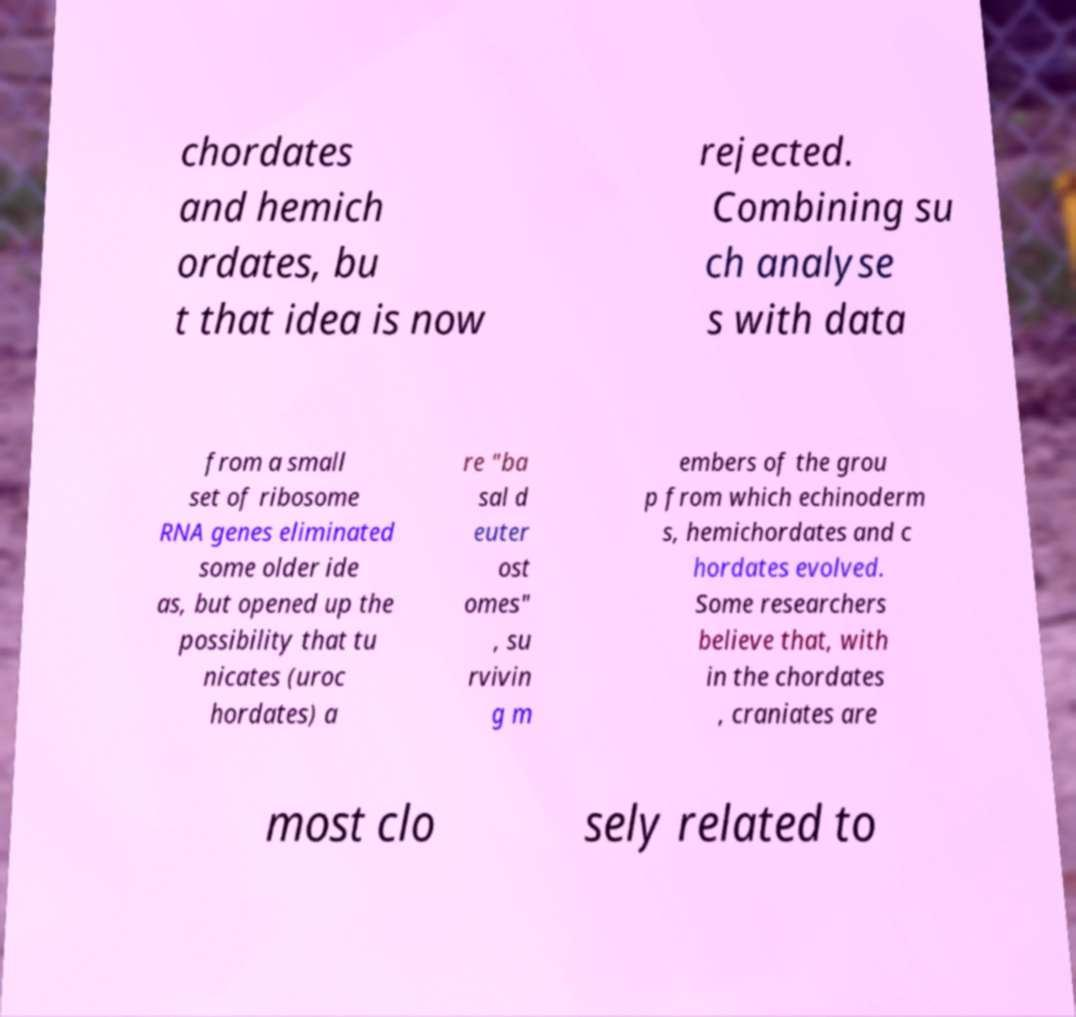Can you accurately transcribe the text from the provided image for me? chordates and hemich ordates, bu t that idea is now rejected. Combining su ch analyse s with data from a small set of ribosome RNA genes eliminated some older ide as, but opened up the possibility that tu nicates (uroc hordates) a re "ba sal d euter ost omes" , su rvivin g m embers of the grou p from which echinoderm s, hemichordates and c hordates evolved. Some researchers believe that, with in the chordates , craniates are most clo sely related to 